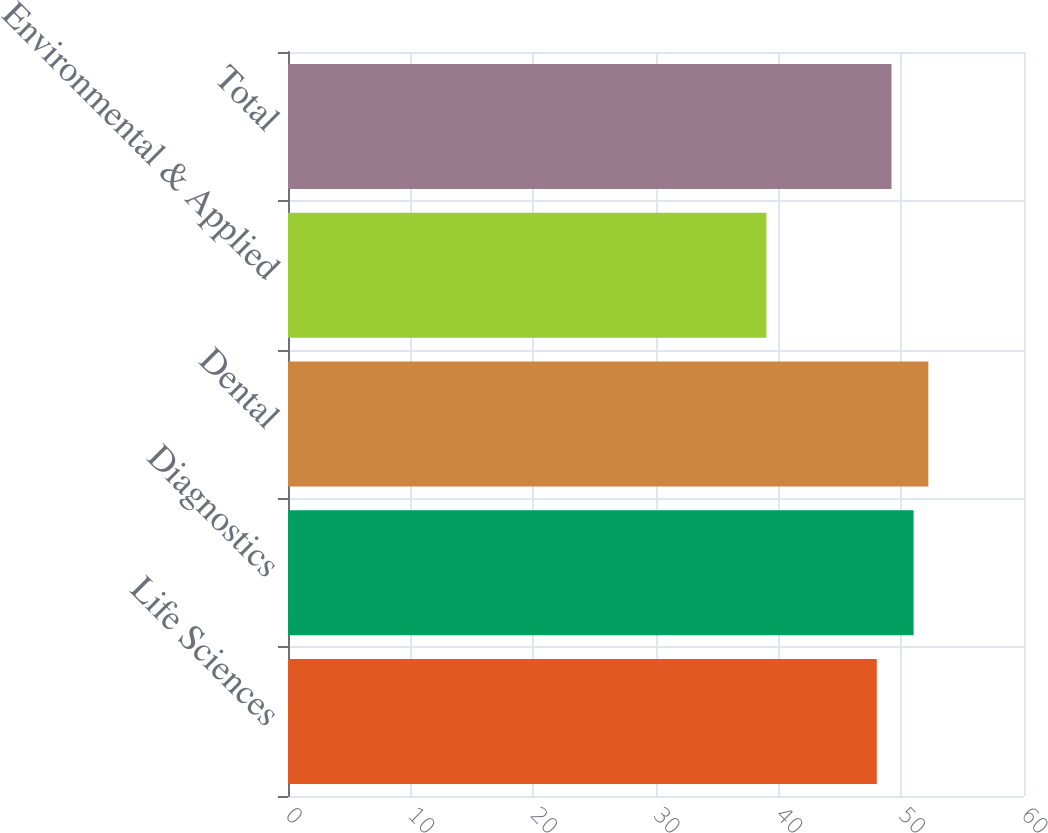Convert chart. <chart><loc_0><loc_0><loc_500><loc_500><bar_chart><fcel>Life Sciences<fcel>Diagnostics<fcel>Dental<fcel>Environmental & Applied<fcel>Total<nl><fcel>48<fcel>51<fcel>52.2<fcel>39<fcel>49.2<nl></chart> 